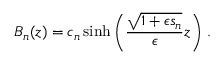Convert formula to latex. <formula><loc_0><loc_0><loc_500><loc_500>B _ { n } ( z ) = c _ { n } \sinh \left ( \frac { \sqrt { 1 + \epsilon s _ { n } } } { \epsilon } z \right ) \, .</formula> 